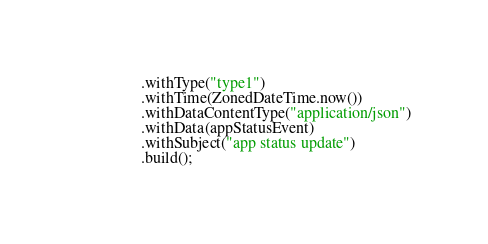Convert code to text. <code><loc_0><loc_0><loc_500><loc_500><_Java_>                .withType("type1")
                .withTime(ZonedDateTime.now())
                .withDataContentType("application/json")
                .withData(appStatusEvent)
                .withSubject("app status update")
                .build();</code> 